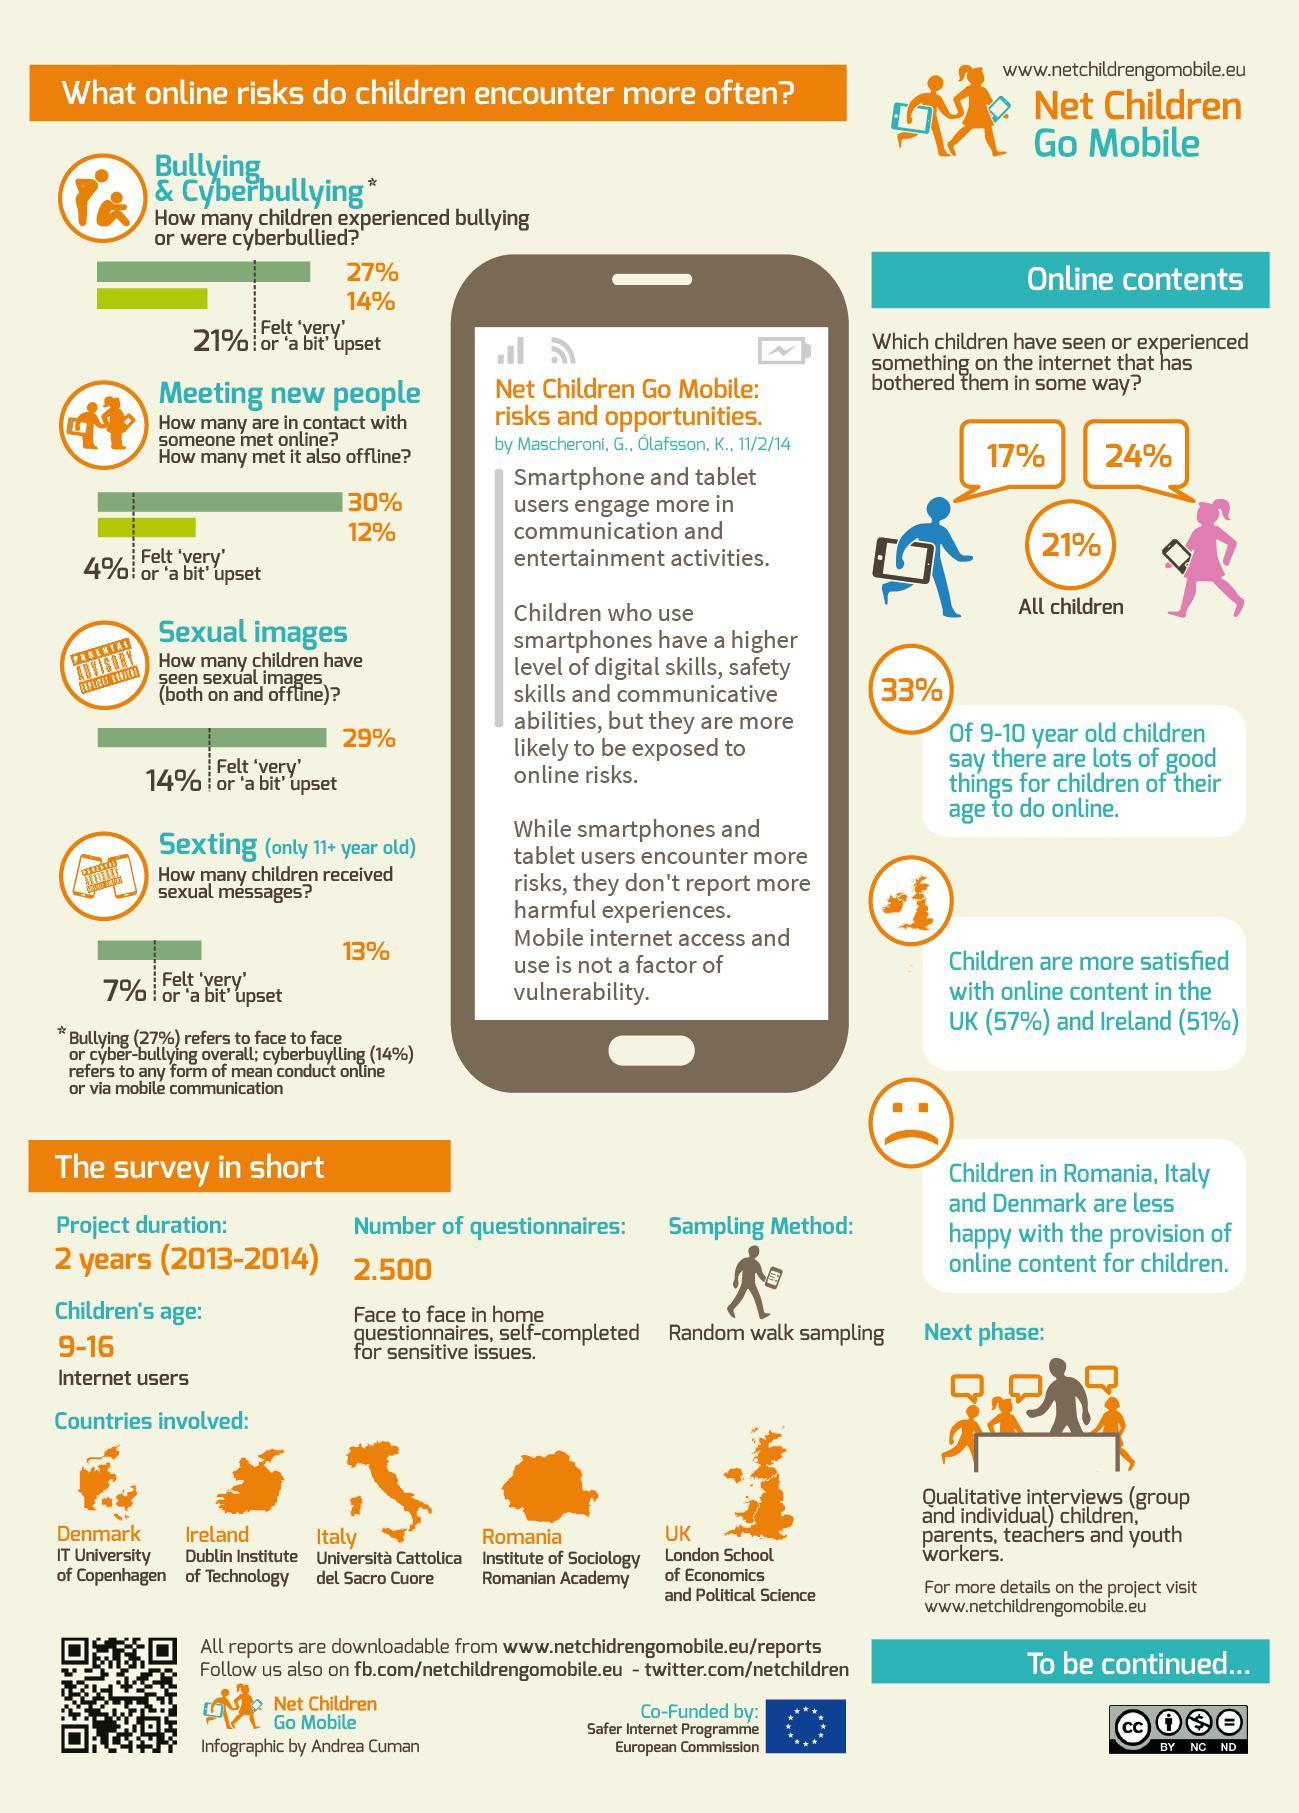What percentage of Girl child have watched something on Internet and got distracted by it?
Answer the question with a short phrase. 24% How many children have met the people whom they saw first through internet? 12% What percentage of children are not satisfied with the online content in UK? 43 Which school from UK which participated in the survey? London school of Economics and Political science What percentage of children went sad or a bit sad after meeting new people offline? 4% 